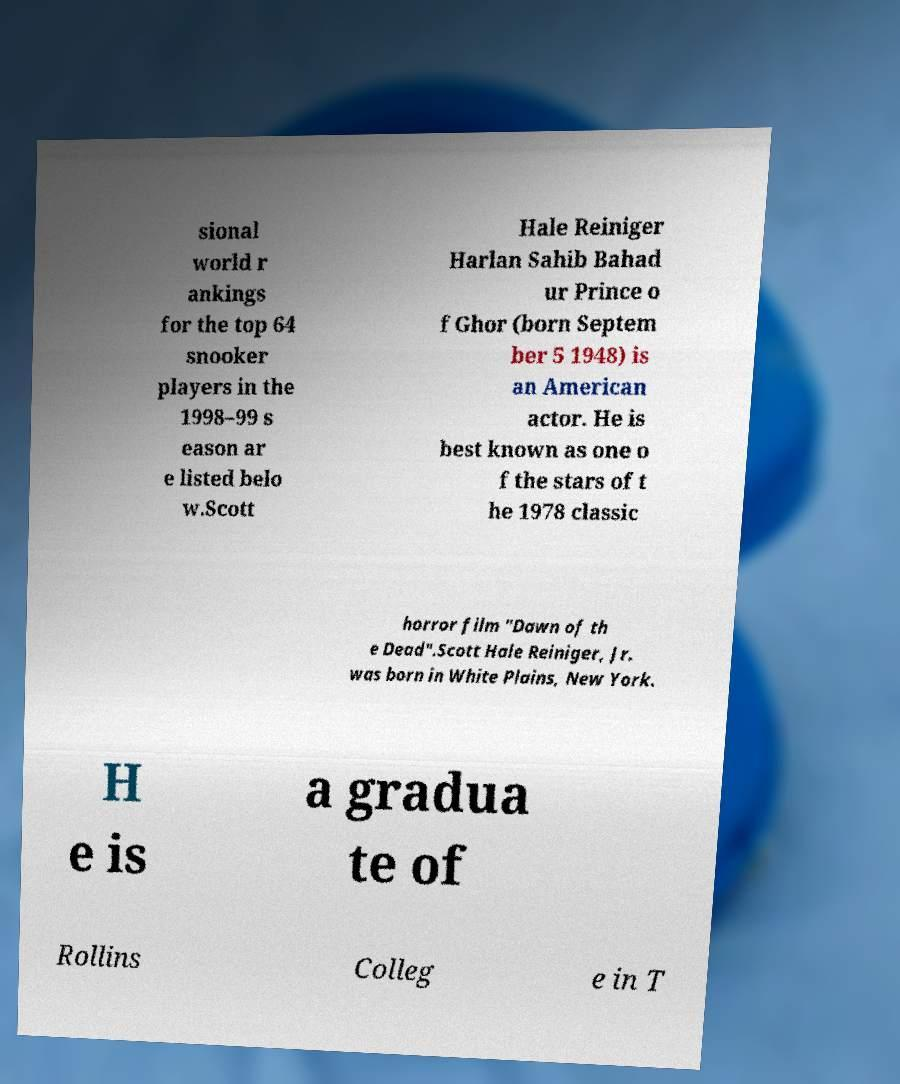What messages or text are displayed in this image? I need them in a readable, typed format. sional world r ankings for the top 64 snooker players in the 1998–99 s eason ar e listed belo w.Scott Hale Reiniger Harlan Sahib Bahad ur Prince o f Ghor (born Septem ber 5 1948) is an American actor. He is best known as one o f the stars of t he 1978 classic horror film "Dawn of th e Dead".Scott Hale Reiniger, Jr. was born in White Plains, New York. H e is a gradua te of Rollins Colleg e in T 